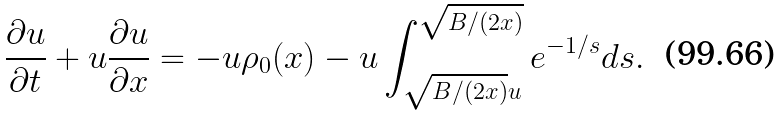<formula> <loc_0><loc_0><loc_500><loc_500>\frac { \partial u } { \partial t } + u \frac { \partial u } { \partial x } = - u \rho _ { 0 } ( x ) - u \int _ { \sqrt { B / ( 2 x ) } u } ^ { \sqrt { B / ( 2 x ) } } e ^ { - 1 / s } d s .</formula> 